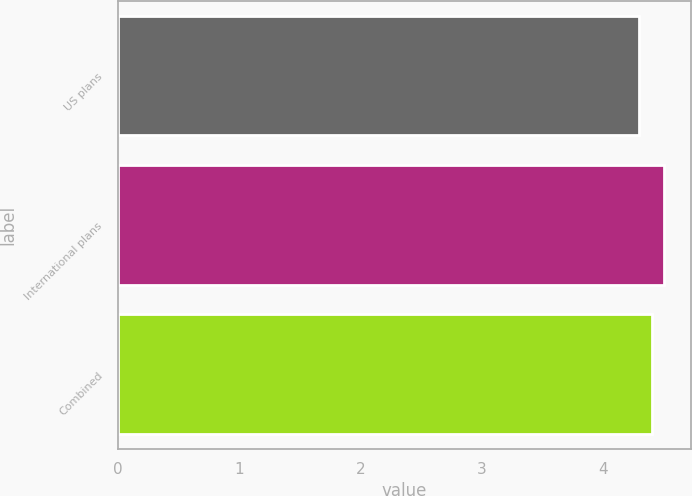Convert chart to OTSL. <chart><loc_0><loc_0><loc_500><loc_500><bar_chart><fcel>US plans<fcel>International plans<fcel>Combined<nl><fcel>4.3<fcel>4.5<fcel>4.4<nl></chart> 